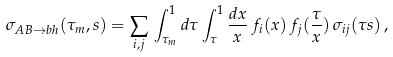Convert formula to latex. <formula><loc_0><loc_0><loc_500><loc_500>\sigma _ { A B \rightarrow b h } ( \tau _ { m } , s ) = \sum _ { i , j } \, \int _ { \tau _ { m } } ^ { 1 } d \tau \int _ { \tau } ^ { 1 } \frac { d x } { x } \, f _ { i } ( x ) \, f _ { j } ( \frac { \tau } { x } ) \, \sigma _ { i j } ( \tau s ) \, ,</formula> 